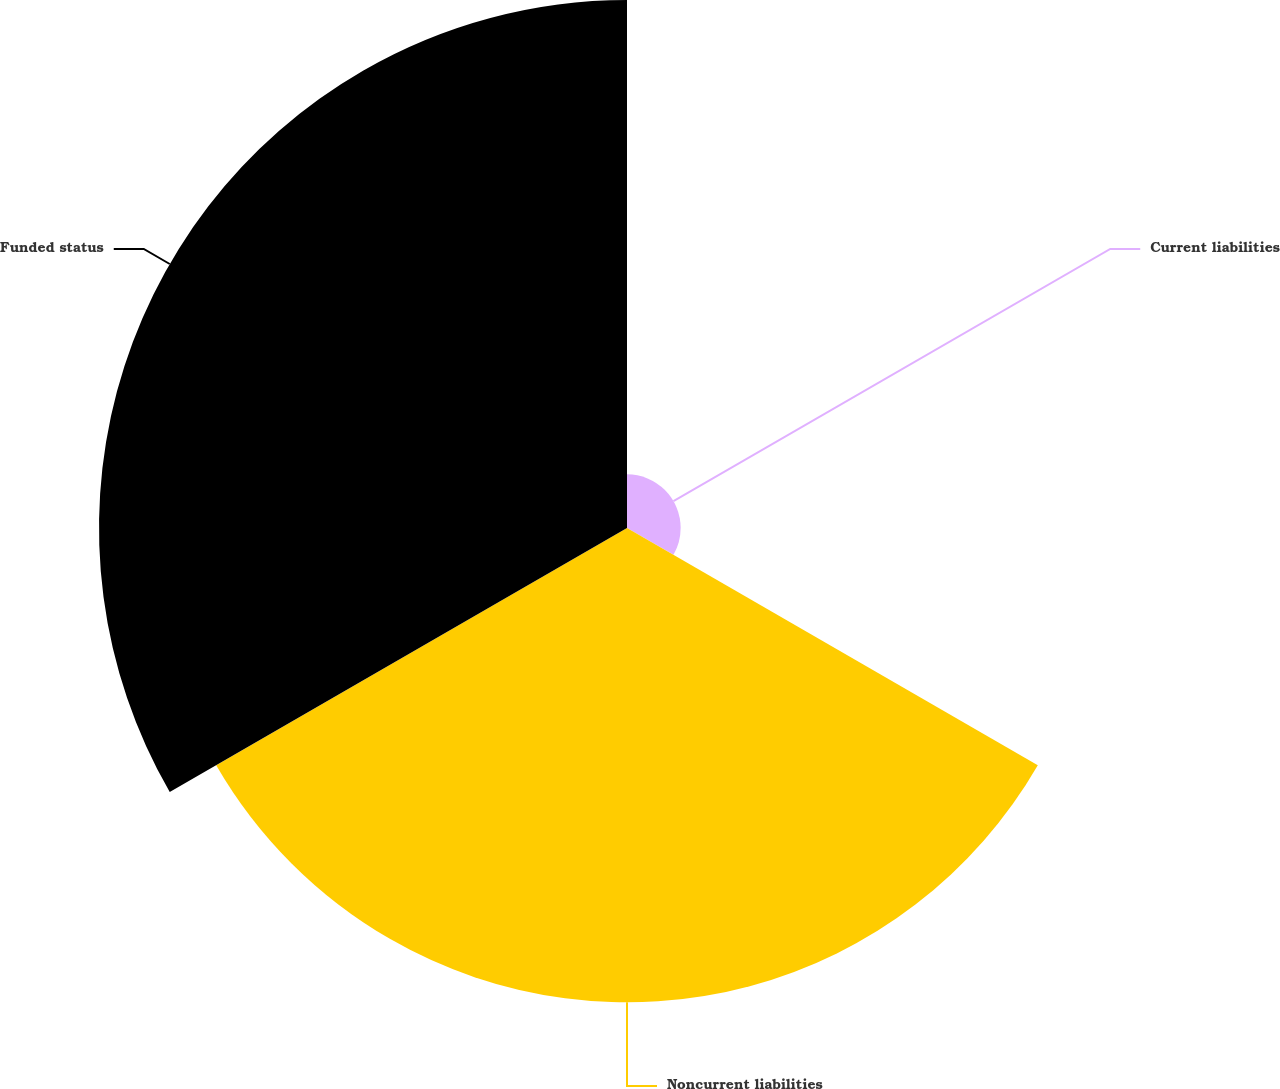Convert chart to OTSL. <chart><loc_0><loc_0><loc_500><loc_500><pie_chart><fcel>Current liabilities<fcel>Noncurrent liabilities<fcel>Funded status<nl><fcel>5.08%<fcel>44.92%<fcel>50.0%<nl></chart> 